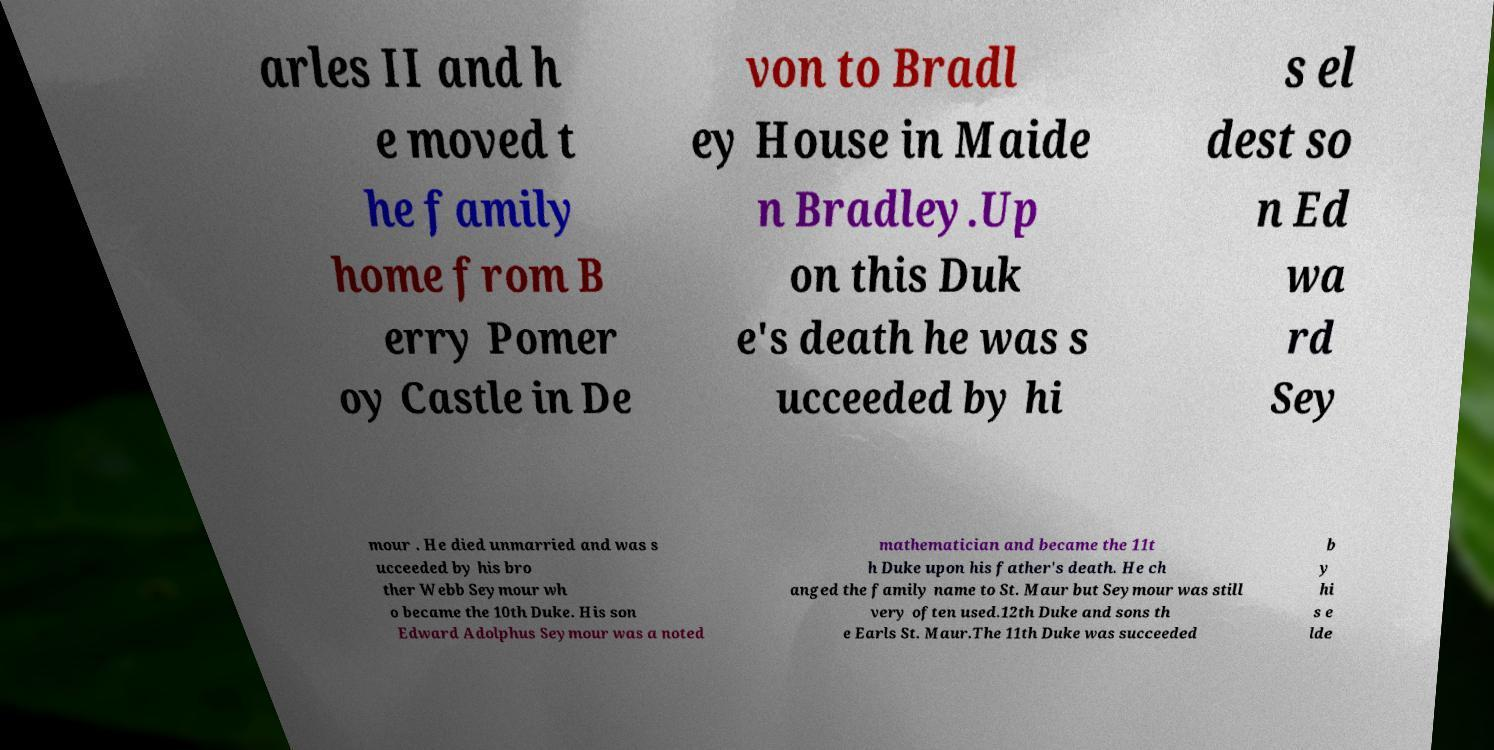Can you accurately transcribe the text from the provided image for me? arles II and h e moved t he family home from B erry Pomer oy Castle in De von to Bradl ey House in Maide n Bradley.Up on this Duk e's death he was s ucceeded by hi s el dest so n Ed wa rd Sey mour . He died unmarried and was s ucceeded by his bro ther Webb Seymour wh o became the 10th Duke. His son Edward Adolphus Seymour was a noted mathematician and became the 11t h Duke upon his father's death. He ch anged the family name to St. Maur but Seymour was still very often used.12th Duke and sons th e Earls St. Maur.The 11th Duke was succeeded b y hi s e lde 